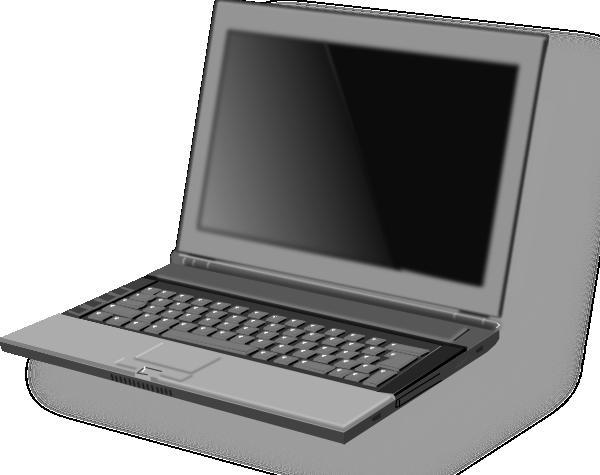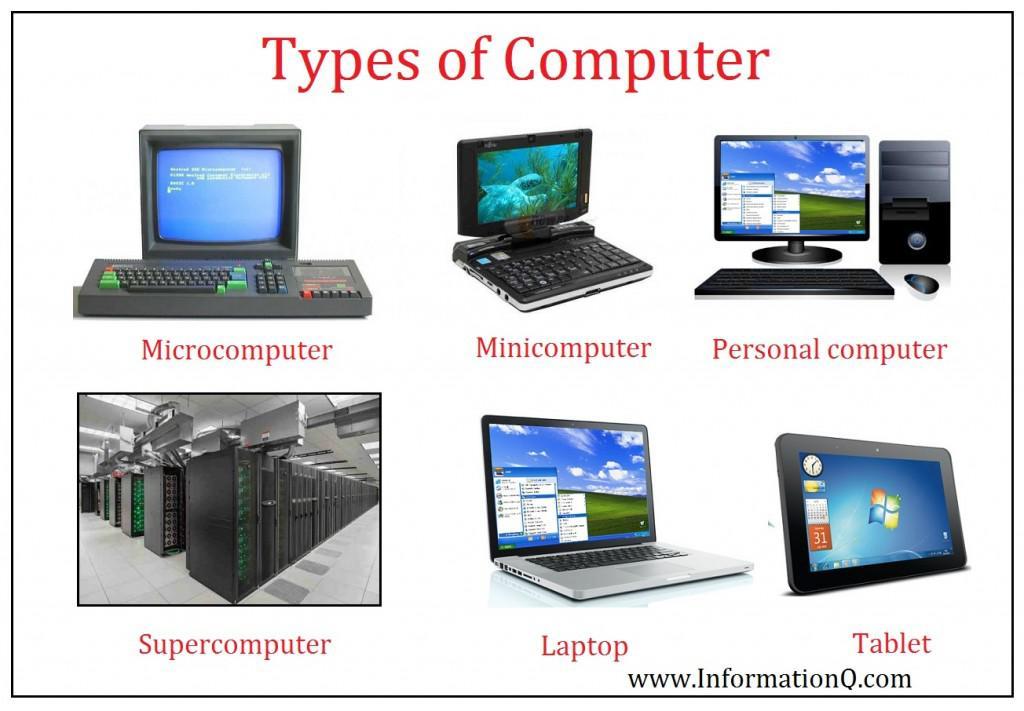The first image is the image on the left, the second image is the image on the right. Considering the images on both sides, is "The laptop in the image on the left is facing right." valid? Answer yes or no. No. 